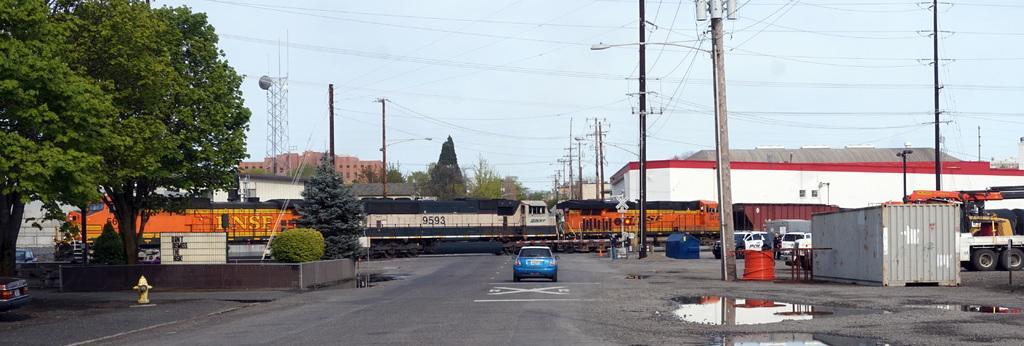Describe this image in one or two sentences. In this image, I can see a train on the railway track and few vehicles on the road. On the left side of the image, I can see a fire hydrant, trees and bushes. There are buildings, current poles and few more trees behind the train. In the background, I can see the sky. On the right side of the image, there is an iron container. 